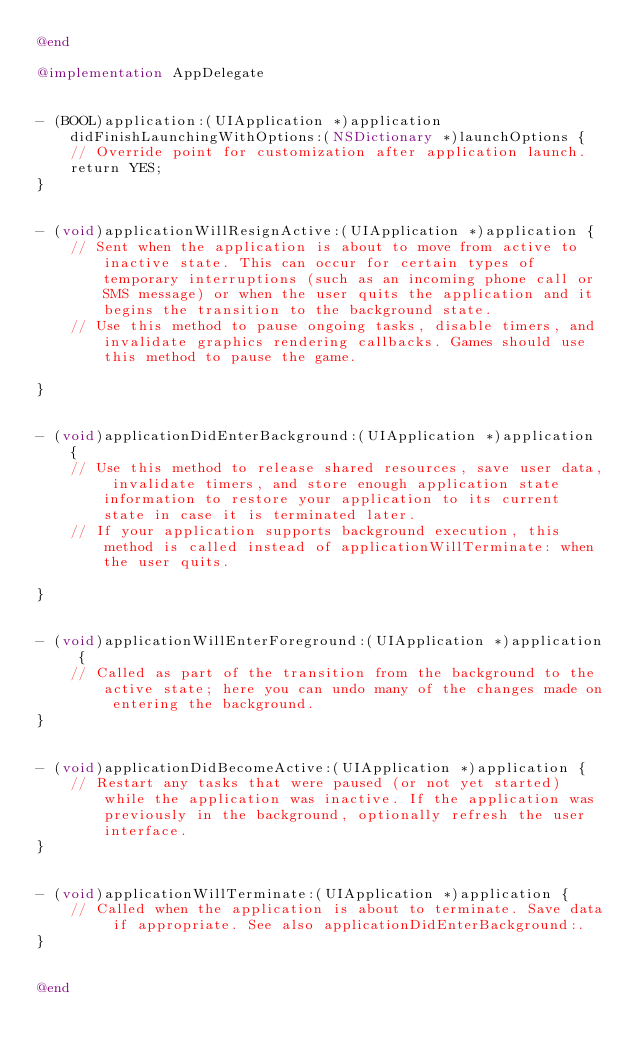<code> <loc_0><loc_0><loc_500><loc_500><_ObjectiveC_>@end

@implementation AppDelegate


- (BOOL)application:(UIApplication *)application didFinishLaunchingWithOptions:(NSDictionary *)launchOptions {
    // Override point for customization after application launch.
    return YES;
}


- (void)applicationWillResignActive:(UIApplication *)application {
    // Sent when the application is about to move from active to inactive state. This can occur for certain types of temporary interruptions (such as an incoming phone call or SMS message) or when the user quits the application and it begins the transition to the background state.
    // Use this method to pause ongoing tasks, disable timers, and invalidate graphics rendering callbacks. Games should use this method to pause the game.

}


- (void)applicationDidEnterBackground:(UIApplication *)application {
    // Use this method to release shared resources, save user data, invalidate timers, and store enough application state information to restore your application to its current state in case it is terminated later.
    // If your application supports background execution, this method is called instead of applicationWillTerminate: when the user quits.

}


- (void)applicationWillEnterForeground:(UIApplication *)application {
    // Called as part of the transition from the background to the active state; here you can undo many of the changes made on entering the background.
}


- (void)applicationDidBecomeActive:(UIApplication *)application {
    // Restart any tasks that were paused (or not yet started) while the application was inactive. If the application was previously in the background, optionally refresh the user interface.
}


- (void)applicationWillTerminate:(UIApplication *)application {
    // Called when the application is about to terminate. Save data if appropriate. See also applicationDidEnterBackground:.
}


@end
</code> 